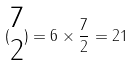Convert formula to latex. <formula><loc_0><loc_0><loc_500><loc_500>( \begin{matrix} 7 \\ 2 \end{matrix} ) = 6 \times \frac { 7 } { 2 } = 2 1</formula> 